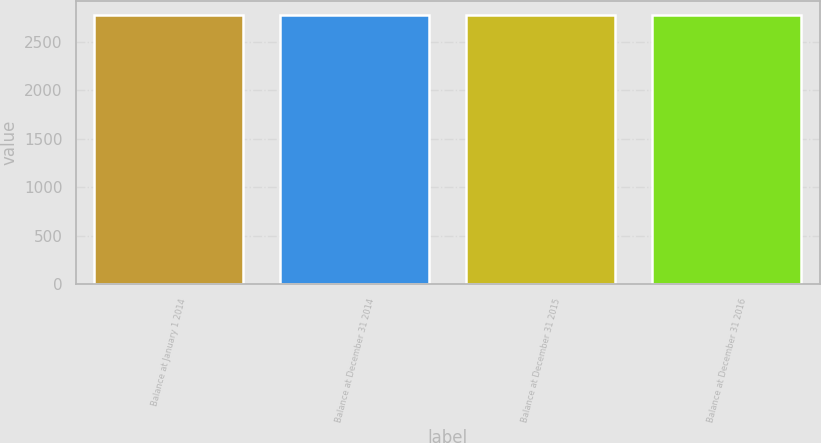<chart> <loc_0><loc_0><loc_500><loc_500><bar_chart><fcel>Balance at January 1 2014<fcel>Balance at December 31 2014<fcel>Balance at December 31 2015<fcel>Balance at December 31 2016<nl><fcel>2774<fcel>2775<fcel>2776<fcel>2777<nl></chart> 